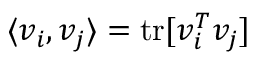Convert formula to latex. <formula><loc_0><loc_0><loc_500><loc_500>\langle v _ { i } , v _ { j } \rangle = t r [ v _ { i } ^ { T } v _ { j } ]</formula> 